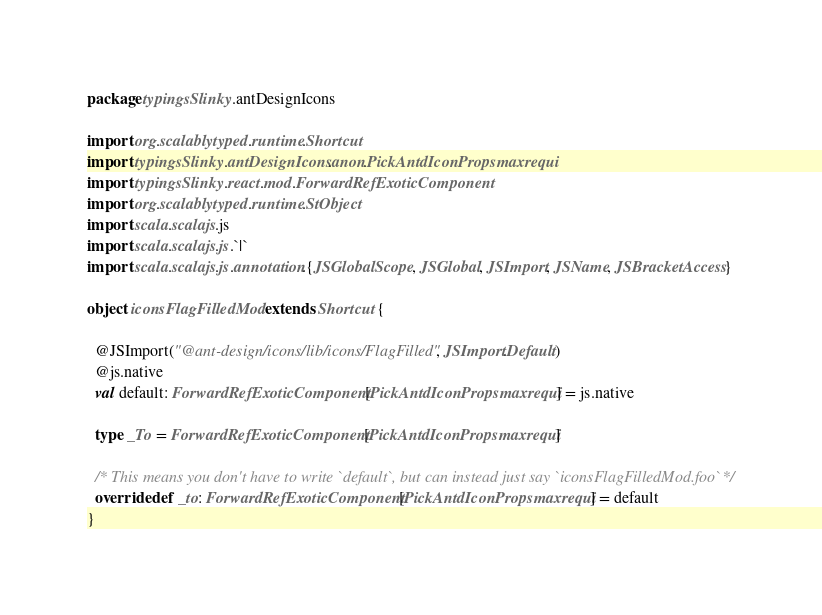Convert code to text. <code><loc_0><loc_0><loc_500><loc_500><_Scala_>package typingsSlinky.antDesignIcons

import org.scalablytyped.runtime.Shortcut
import typingsSlinky.antDesignIcons.anon.PickAntdIconPropsmaxrequi
import typingsSlinky.react.mod.ForwardRefExoticComponent
import org.scalablytyped.runtime.StObject
import scala.scalajs.js
import scala.scalajs.js.`|`
import scala.scalajs.js.annotation.{JSGlobalScope, JSGlobal, JSImport, JSName, JSBracketAccess}

object iconsFlagFilledMod extends Shortcut {
  
  @JSImport("@ant-design/icons/lib/icons/FlagFilled", JSImport.Default)
  @js.native
  val default: ForwardRefExoticComponent[PickAntdIconPropsmaxrequi] = js.native
  
  type _To = ForwardRefExoticComponent[PickAntdIconPropsmaxrequi]
  
  /* This means you don't have to write `default`, but can instead just say `iconsFlagFilledMod.foo` */
  override def _to: ForwardRefExoticComponent[PickAntdIconPropsmaxrequi] = default
}
</code> 